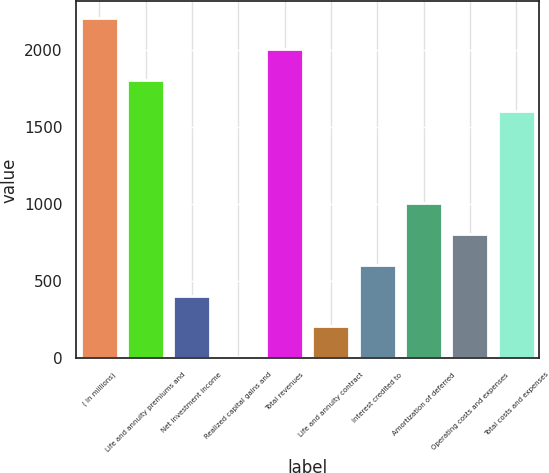Convert chart to OTSL. <chart><loc_0><loc_0><loc_500><loc_500><bar_chart><fcel>( in millions)<fcel>Life and annuity premiums and<fcel>Net investment income<fcel>Realized capital gains and<fcel>Total revenues<fcel>Life and annuity contract<fcel>Interest credited to<fcel>Amortization of deferred<fcel>Operating costs and expenses<fcel>Total costs and expenses<nl><fcel>2205.8<fcel>1806.2<fcel>407.6<fcel>8<fcel>2006<fcel>207.8<fcel>607.4<fcel>1007<fcel>807.2<fcel>1606.4<nl></chart> 